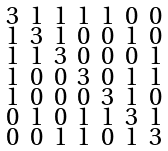<formula> <loc_0><loc_0><loc_500><loc_500>\begin{smallmatrix} 3 & 1 & 1 & 1 & 1 & 0 & 0 \\ 1 & 3 & 1 & 0 & 0 & 1 & 0 \\ 1 & 1 & 3 & 0 & 0 & 0 & 1 \\ 1 & 0 & 0 & 3 & 0 & 1 & 1 \\ 1 & 0 & 0 & 0 & 3 & 1 & 0 \\ 0 & 1 & 0 & 1 & 1 & 3 & 1 \\ 0 & 0 & 1 & 1 & 0 & 1 & 3 \end{smallmatrix}</formula> 